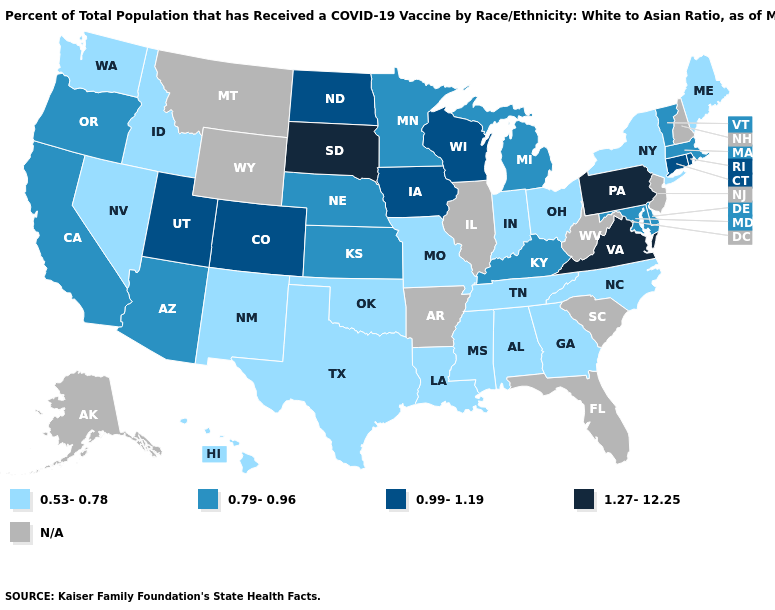Does Iowa have the highest value in the USA?
Write a very short answer. No. What is the value of Arkansas?
Short answer required. N/A. What is the value of Colorado?
Concise answer only. 0.99-1.19. Name the states that have a value in the range N/A?
Give a very brief answer. Alaska, Arkansas, Florida, Illinois, Montana, New Hampshire, New Jersey, South Carolina, West Virginia, Wyoming. Name the states that have a value in the range N/A?
Concise answer only. Alaska, Arkansas, Florida, Illinois, Montana, New Hampshire, New Jersey, South Carolina, West Virginia, Wyoming. What is the value of South Dakota?
Be succinct. 1.27-12.25. Which states have the lowest value in the Northeast?
Be succinct. Maine, New York. Does Pennsylvania have the highest value in the Northeast?
Quick response, please. Yes. What is the highest value in the USA?
Concise answer only. 1.27-12.25. What is the value of South Dakota?
Write a very short answer. 1.27-12.25. What is the value of New Hampshire?
Be succinct. N/A. Does the first symbol in the legend represent the smallest category?
Give a very brief answer. Yes. Which states have the highest value in the USA?
Quick response, please. Pennsylvania, South Dakota, Virginia. What is the value of Alabama?
Give a very brief answer. 0.53-0.78. 